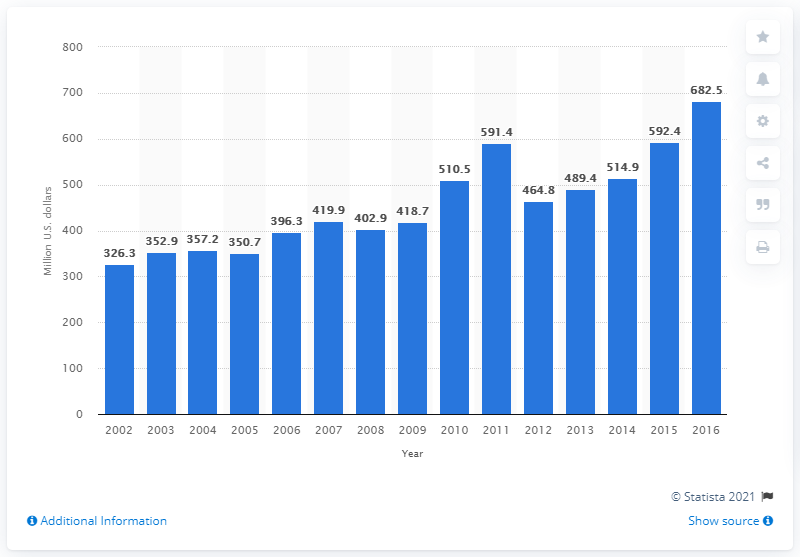Outline some significant characteristics in this image. In 2016, the value of U.S. product shipments of vinegar and cider was 682.5 million dollars. 